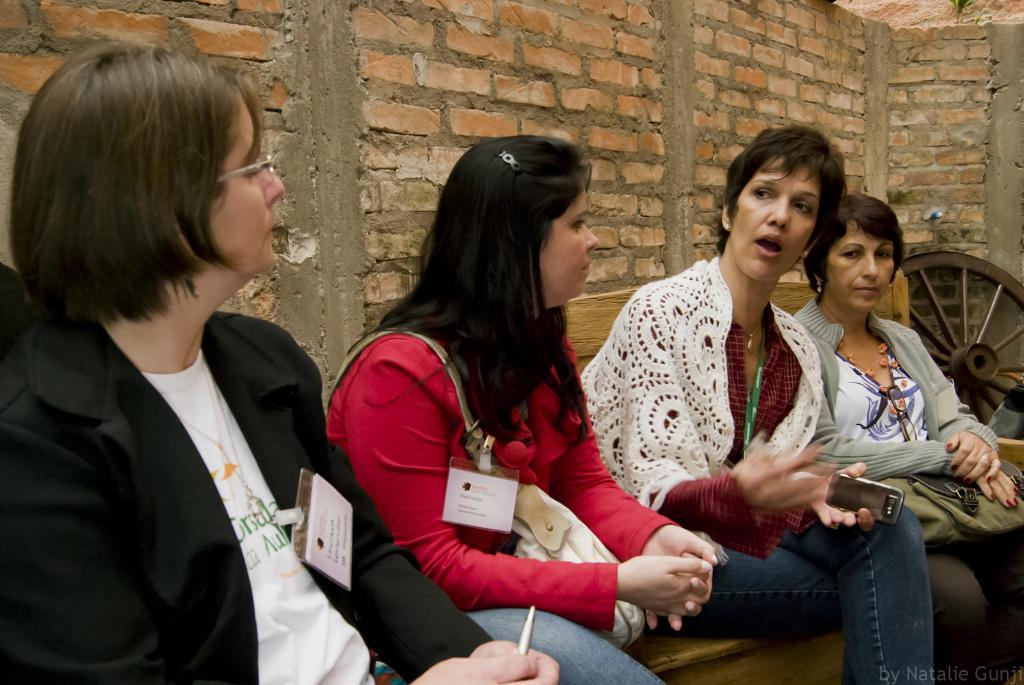What is located in the left corner of the image? There is an object in the left corner of the image. How many people are sitting on the bench in the foreground? There are four people sitting on a bench in the foreground. What can be seen in the background of the image? There is a brick wall in the background of the image. What type of tooth is visible in the image? There is no tooth present in the image. Can you describe the berries growing on the brick wall in the background? There are no berries growing on the brick wall in the image; it is a brick wall without any vegetation. 